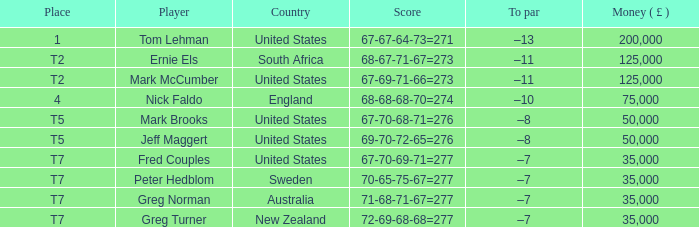In the context of "united states" and player "mark brooks," what is the score? 67-70-68-71=276. 